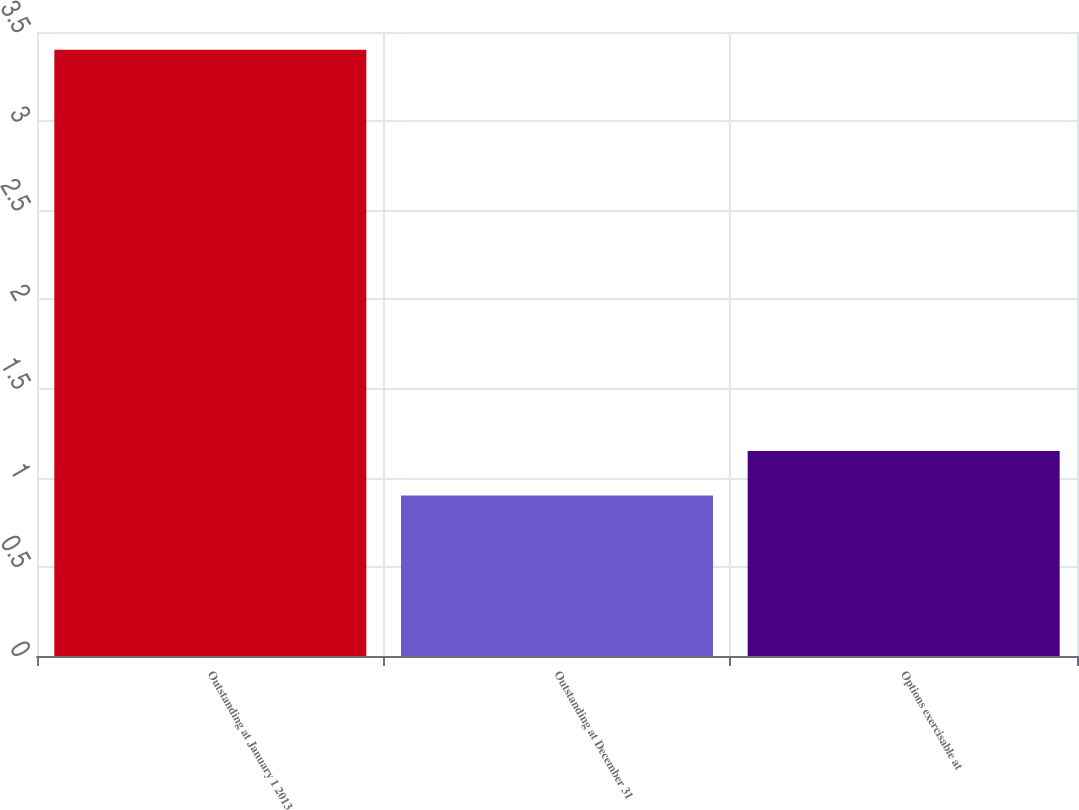<chart> <loc_0><loc_0><loc_500><loc_500><bar_chart><fcel>Outstanding at January 1 2013<fcel>Outstanding at December 31<fcel>Options exercisable at<nl><fcel>3.4<fcel>0.9<fcel>1.15<nl></chart> 